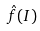Convert formula to latex. <formula><loc_0><loc_0><loc_500><loc_500>\hat { f } ( I )</formula> 